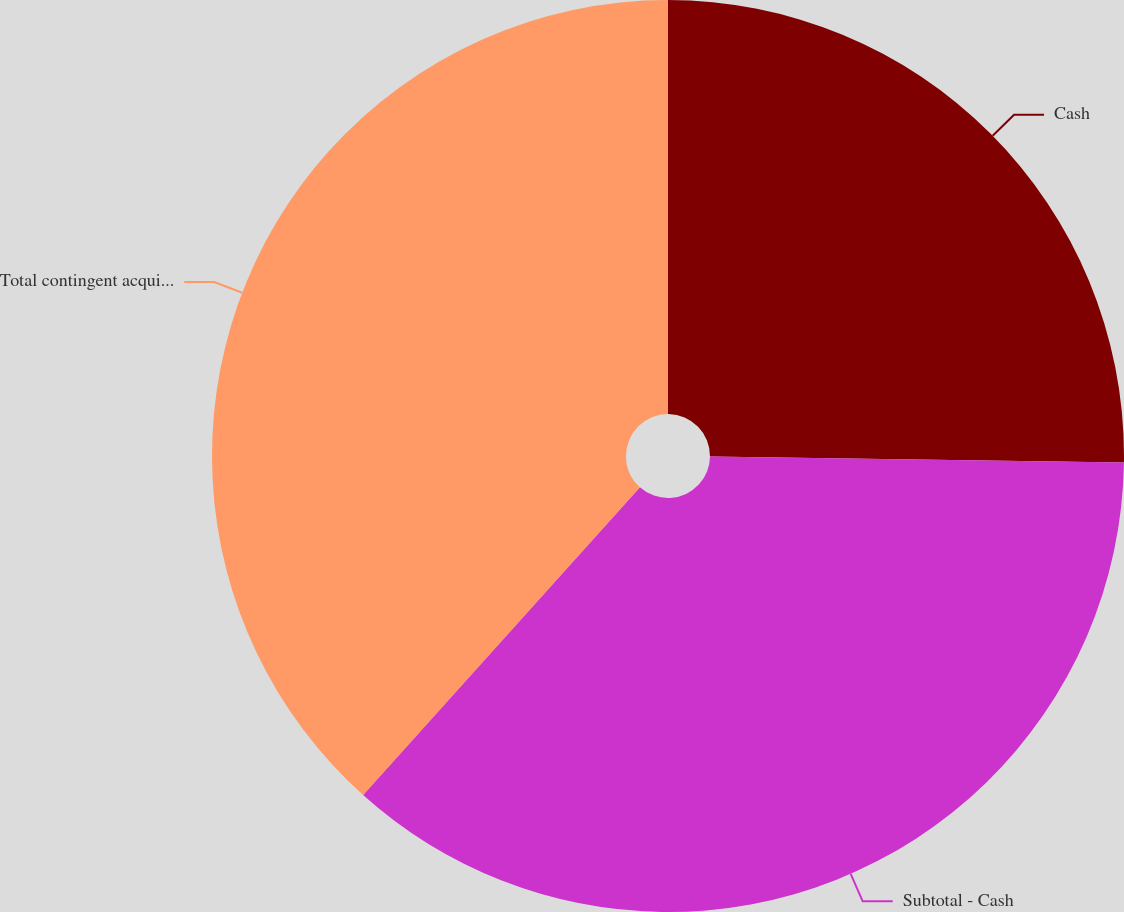<chart> <loc_0><loc_0><loc_500><loc_500><pie_chart><fcel>Cash<fcel>Subtotal - Cash<fcel>Total contingent acquisition<nl><fcel>25.22%<fcel>36.43%<fcel>38.34%<nl></chart> 